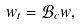Convert formula to latex. <formula><loc_0><loc_0><loc_500><loc_500>w _ { t } = \mathcal { B } _ { c } w ,</formula> 